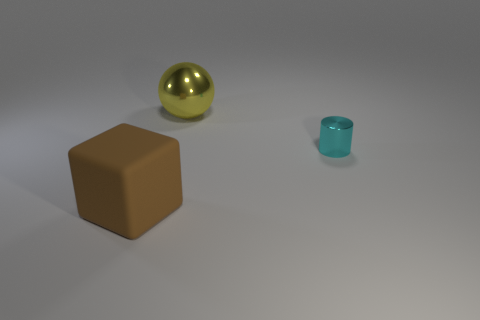Are there any other things that have the same size as the metallic cylinder?
Offer a terse response. No. Are there more large spheres that are left of the tiny cyan metal cylinder than tiny metal things left of the yellow ball?
Your answer should be compact. Yes. Are the brown thing and the big thing behind the big brown cube made of the same material?
Keep it short and to the point. No. Is there any other thing that has the same shape as the cyan metallic object?
Provide a short and direct response. No. There is a object that is behind the big matte block and in front of the large yellow metal object; what color is it?
Offer a very short reply. Cyan. There is a big object behind the big rubber cube; what is its shape?
Your response must be concise. Sphere. What is the size of the metallic thing in front of the big object behind the brown object that is on the left side of the large yellow ball?
Your response must be concise. Small. There is a metallic object right of the big sphere; how many large metal things are to the left of it?
Make the answer very short. 1. How big is the object that is in front of the shiny sphere and left of the shiny cylinder?
Ensure brevity in your answer.  Large. What number of metal objects are either tiny cyan cylinders or large spheres?
Provide a succinct answer. 2. 